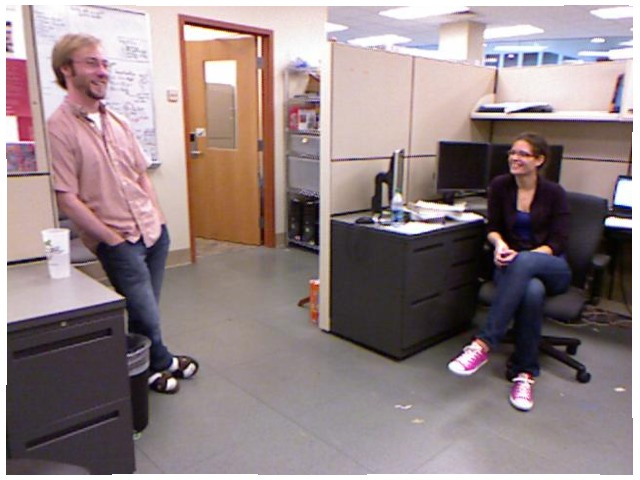<image>
Is there a woman in front of the chair? No. The woman is not in front of the chair. The spatial positioning shows a different relationship between these objects. Is the women on the chair? Yes. Looking at the image, I can see the women is positioned on top of the chair, with the chair providing support. Where is the door in relation to the floor? Is it on the floor? No. The door is not positioned on the floor. They may be near each other, but the door is not supported by or resting on top of the floor. Is the guy on the cup? No. The guy is not positioned on the cup. They may be near each other, but the guy is not supported by or resting on top of the cup. 